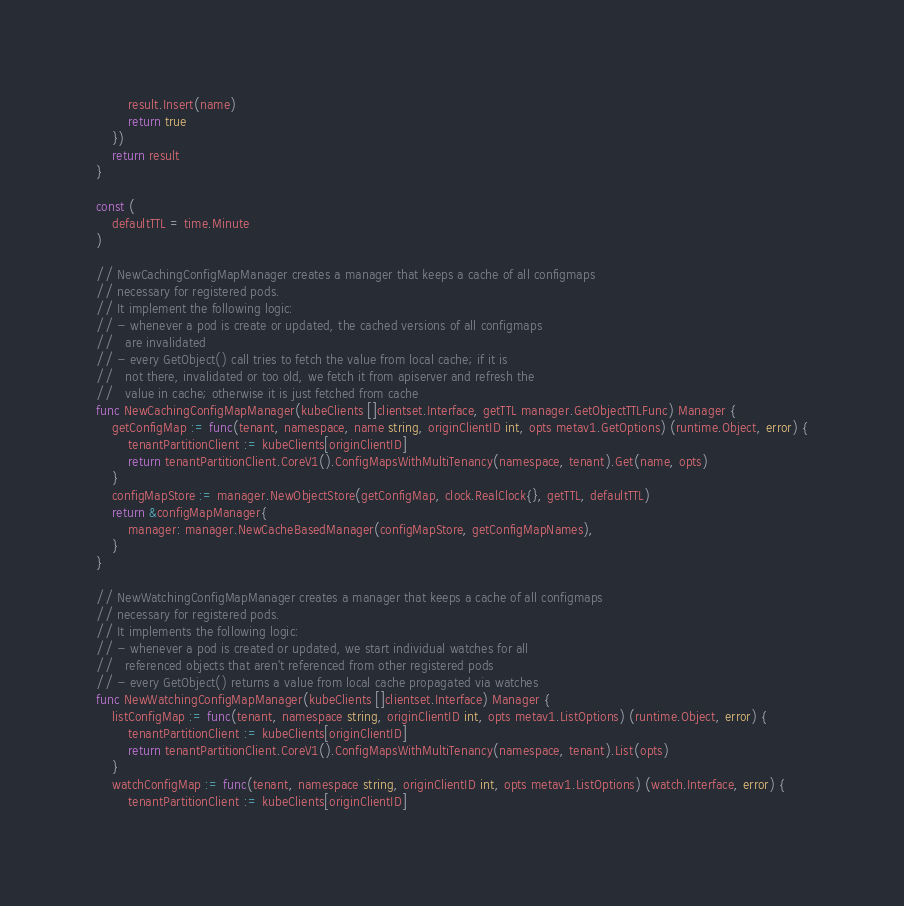<code> <loc_0><loc_0><loc_500><loc_500><_Go_>		result.Insert(name)
		return true
	})
	return result
}

const (
	defaultTTL = time.Minute
)

// NewCachingConfigMapManager creates a manager that keeps a cache of all configmaps
// necessary for registered pods.
// It implement the following logic:
// - whenever a pod is create or updated, the cached versions of all configmaps
//   are invalidated
// - every GetObject() call tries to fetch the value from local cache; if it is
//   not there, invalidated or too old, we fetch it from apiserver and refresh the
//   value in cache; otherwise it is just fetched from cache
func NewCachingConfigMapManager(kubeClients []clientset.Interface, getTTL manager.GetObjectTTLFunc) Manager {
	getConfigMap := func(tenant, namespace, name string, originClientID int, opts metav1.GetOptions) (runtime.Object, error) {
		tenantPartitionClient := kubeClients[originClientID]
		return tenantPartitionClient.CoreV1().ConfigMapsWithMultiTenancy(namespace, tenant).Get(name, opts)
	}
	configMapStore := manager.NewObjectStore(getConfigMap, clock.RealClock{}, getTTL, defaultTTL)
	return &configMapManager{
		manager: manager.NewCacheBasedManager(configMapStore, getConfigMapNames),
	}
}

// NewWatchingConfigMapManager creates a manager that keeps a cache of all configmaps
// necessary for registered pods.
// It implements the following logic:
// - whenever a pod is created or updated, we start individual watches for all
//   referenced objects that aren't referenced from other registered pods
// - every GetObject() returns a value from local cache propagated via watches
func NewWatchingConfigMapManager(kubeClients []clientset.Interface) Manager {
	listConfigMap := func(tenant, namespace string, originClientID int, opts metav1.ListOptions) (runtime.Object, error) {
		tenantPartitionClient := kubeClients[originClientID]
		return tenantPartitionClient.CoreV1().ConfigMapsWithMultiTenancy(namespace, tenant).List(opts)
	}
	watchConfigMap := func(tenant, namespace string, originClientID int, opts metav1.ListOptions) (watch.Interface, error) {
		tenantPartitionClient := kubeClients[originClientID]</code> 